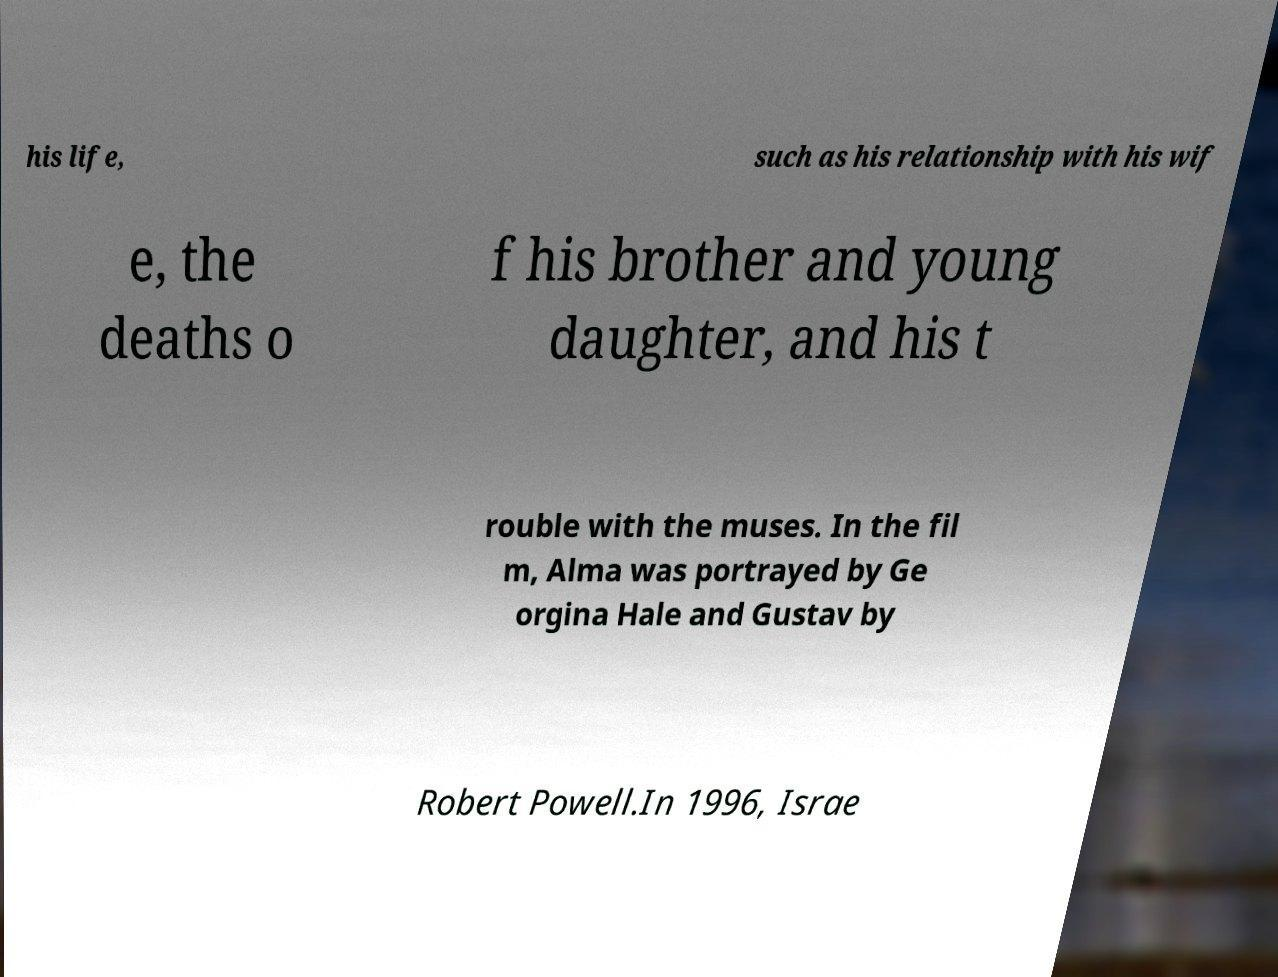Can you read and provide the text displayed in the image?This photo seems to have some interesting text. Can you extract and type it out for me? his life, such as his relationship with his wif e, the deaths o f his brother and young daughter, and his t rouble with the muses. In the fil m, Alma was portrayed by Ge orgina Hale and Gustav by Robert Powell.In 1996, Israe 